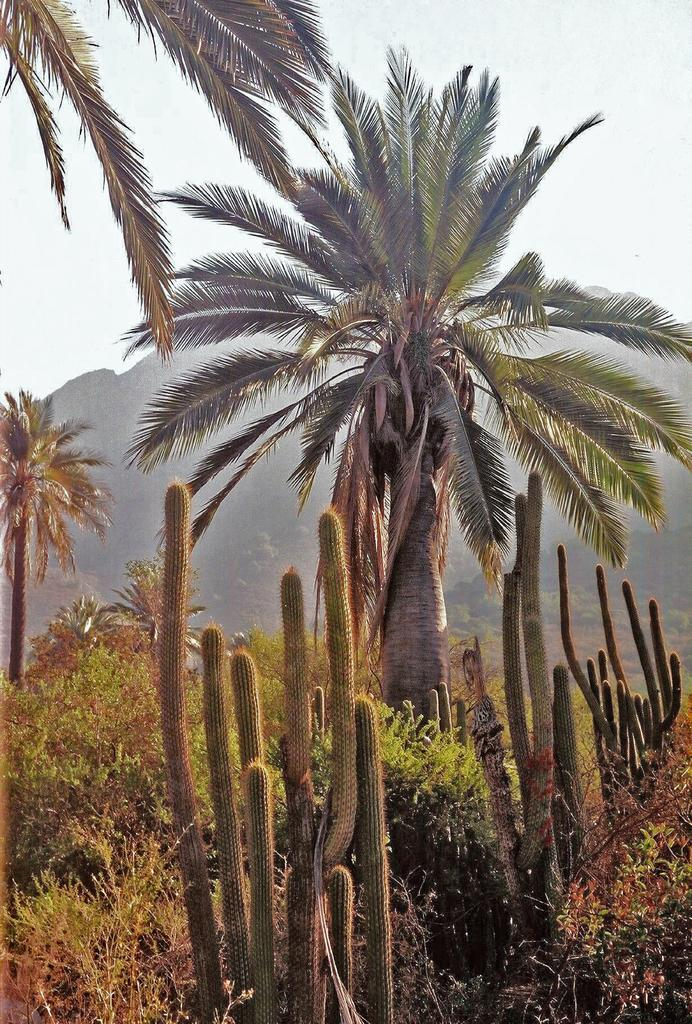What type of vegetation can be seen in the image? There are trees and cactus plants in the image. Where are the plants located in the image? There are plants at the bottom of the image. What can be seen in the background of the image? There are hills and the sky visible in the background of the image. What type of account is being discussed in the meeting in the image? There is no meeting or account present in the image; it features trees, cactus plants, and hills. Can you tell me how many roads are visible in the image? There are no roads visible in the image; it features trees, cactus plants, and hills. 